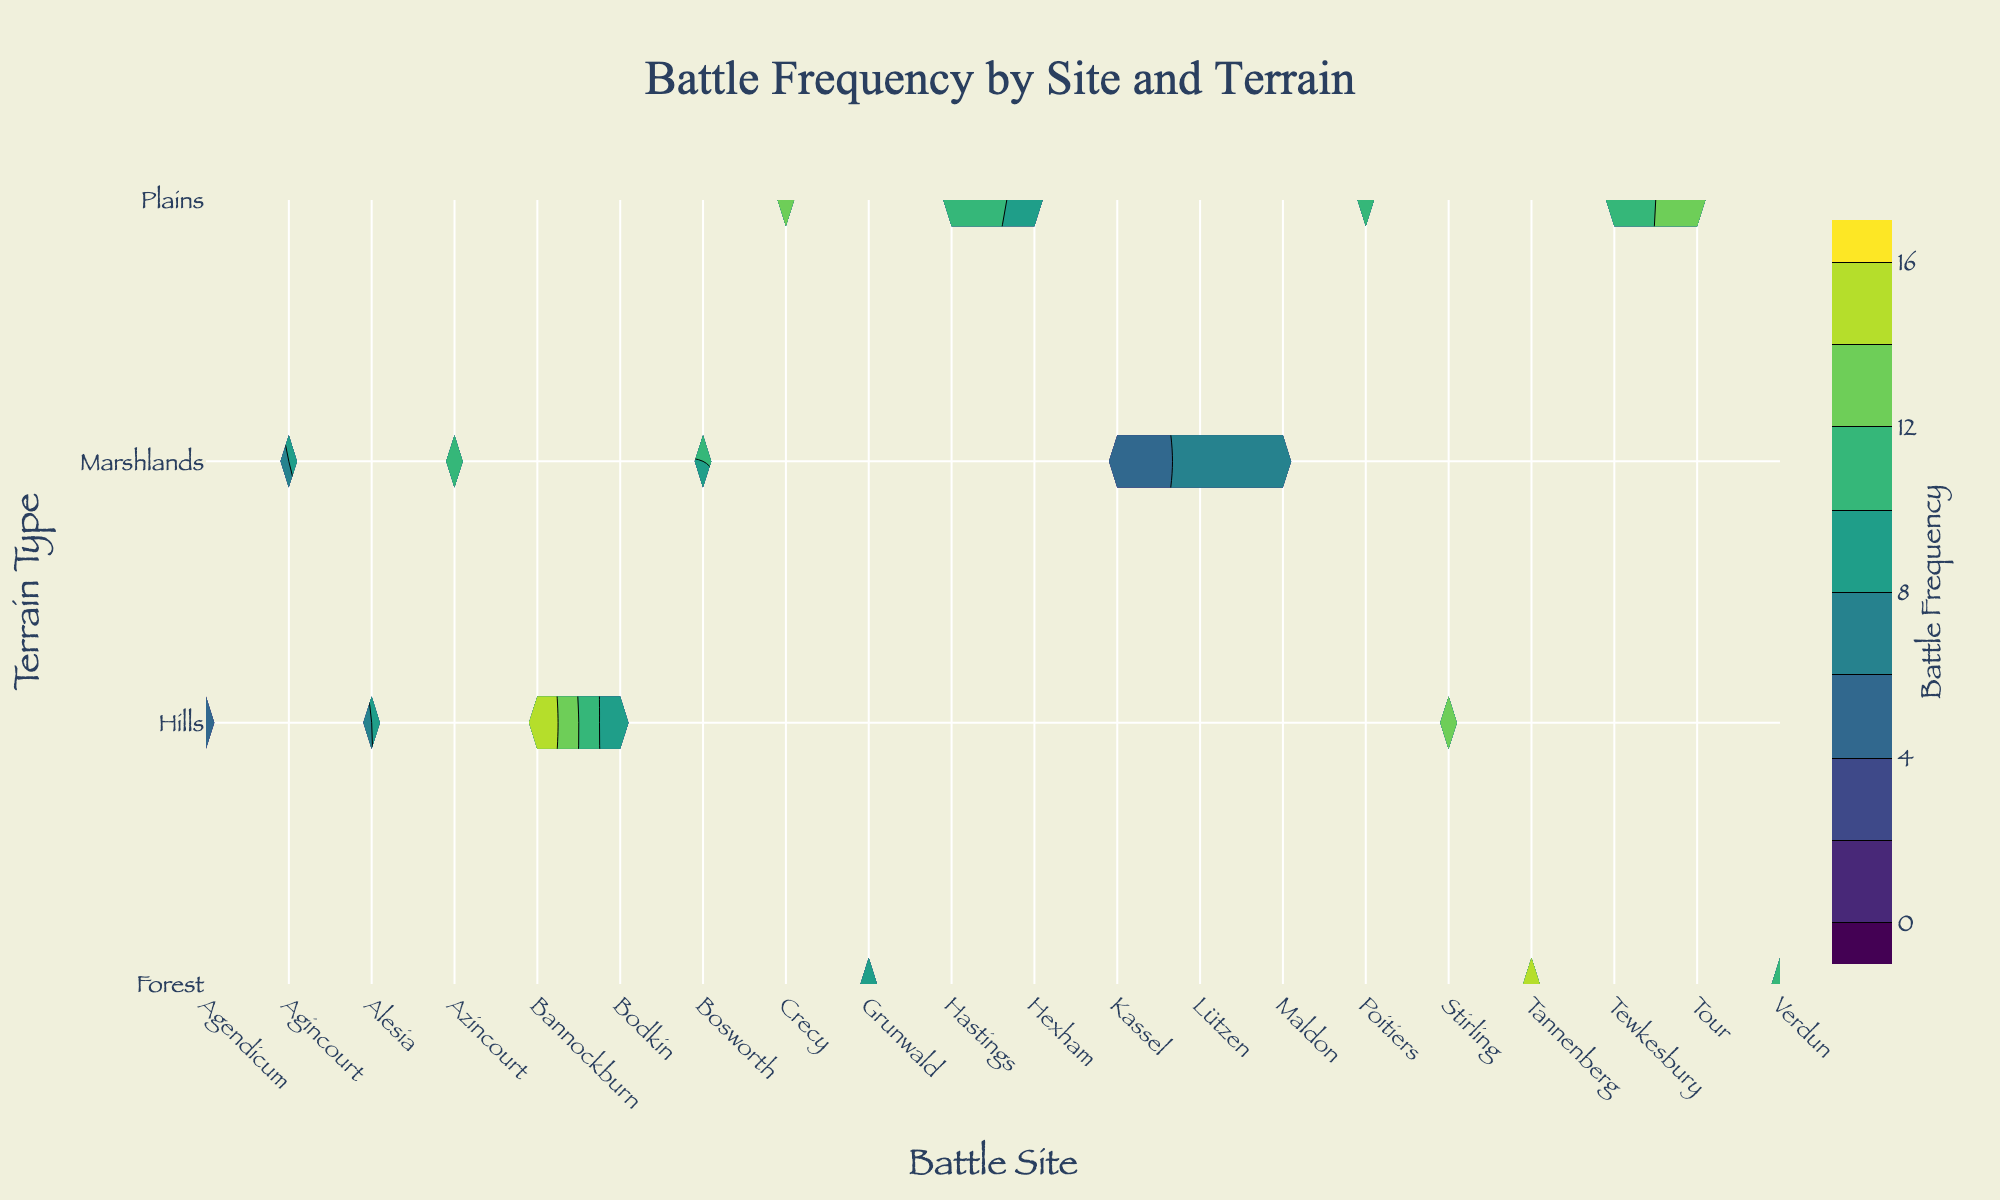What's the title of the figure? The title is usually located at the top center of the figure. Referencing the provided code, the figure's title is "Battle Frequency by Site and Terrain".
Answer: Battle Frequency by Site and Terrain Which Battle Site has the highest frequency of battles in the Hills terrain? Look at the contours representing Hills terrain on the y-axis. Identify the highest frequency value and its corresponding battle site along the x-axis. Bannockburn shows the highest contour value in this terrain.
Answer: Bannockburn How many battle sites are represented in the figure? Count the number of unique battle sites listed along the x-axis. By reading from the pivot table, there are 15 unique battle sites.
Answer: 15 What is the frequency of the battles at Verdun in the Forest terrain? Find the intersection of Verdun on the x-axis and Forest on the y-axis, then read the frequency value. The count shows a frequency of 10.
Answer: 10 Which terrain type has the most frequent battles on average, and what is that average frequency? Calculate the average frequency for each terrain type by adding all the frequency values per terrain type and dividing by the number of battle sites under each terrain. Hills = (16+14+8+5+8)/5 = 10.2; Plains = (12+11+13+14+10+9)/6 = 11.5; Marshlands = (8+10+7+11+6+4)/6 = 7.67; Forest = (9+15+10)/3 = 11.33. Plains have the highest average frequency of battles, 11.5.
Answer: Plains, 11.5 Between the Marshlands terrain at Agincourt and the Plains terrain at Crecy, which has a higher battle frequency and by how much? Locate the frequencies on the contours for Agincourt in Marshlands and Crecy in Plains. Agincourt shows a frequency of 8, and Crecy shows 13. The difference is 13 - 8 = 5.
Answer: Crecy by 5 What's the range of battle frequencies represented in this contour plot? Review the minimum and maximum values on the color bar representing battle frequency. From the code, the contours start at 0 and end at 16.
Answer: 0 to 16 In which terrain type do we see the least frequent battles at Kassel? Find the frequency value at Kassel under Marshlands on the y-axis. The contour shows a frequency of 4, making it the least frequent.
Answer: Marshlands For the battle site of Tannenberg in Forest terrain, what is the difference in frequency compared to Grunwald in the same terrain? Identify and compare the frequencies found on the contours for Tannenberg (15) and Grunwald (9). The difference is 15 - 9 = 6.
Answer: 6 